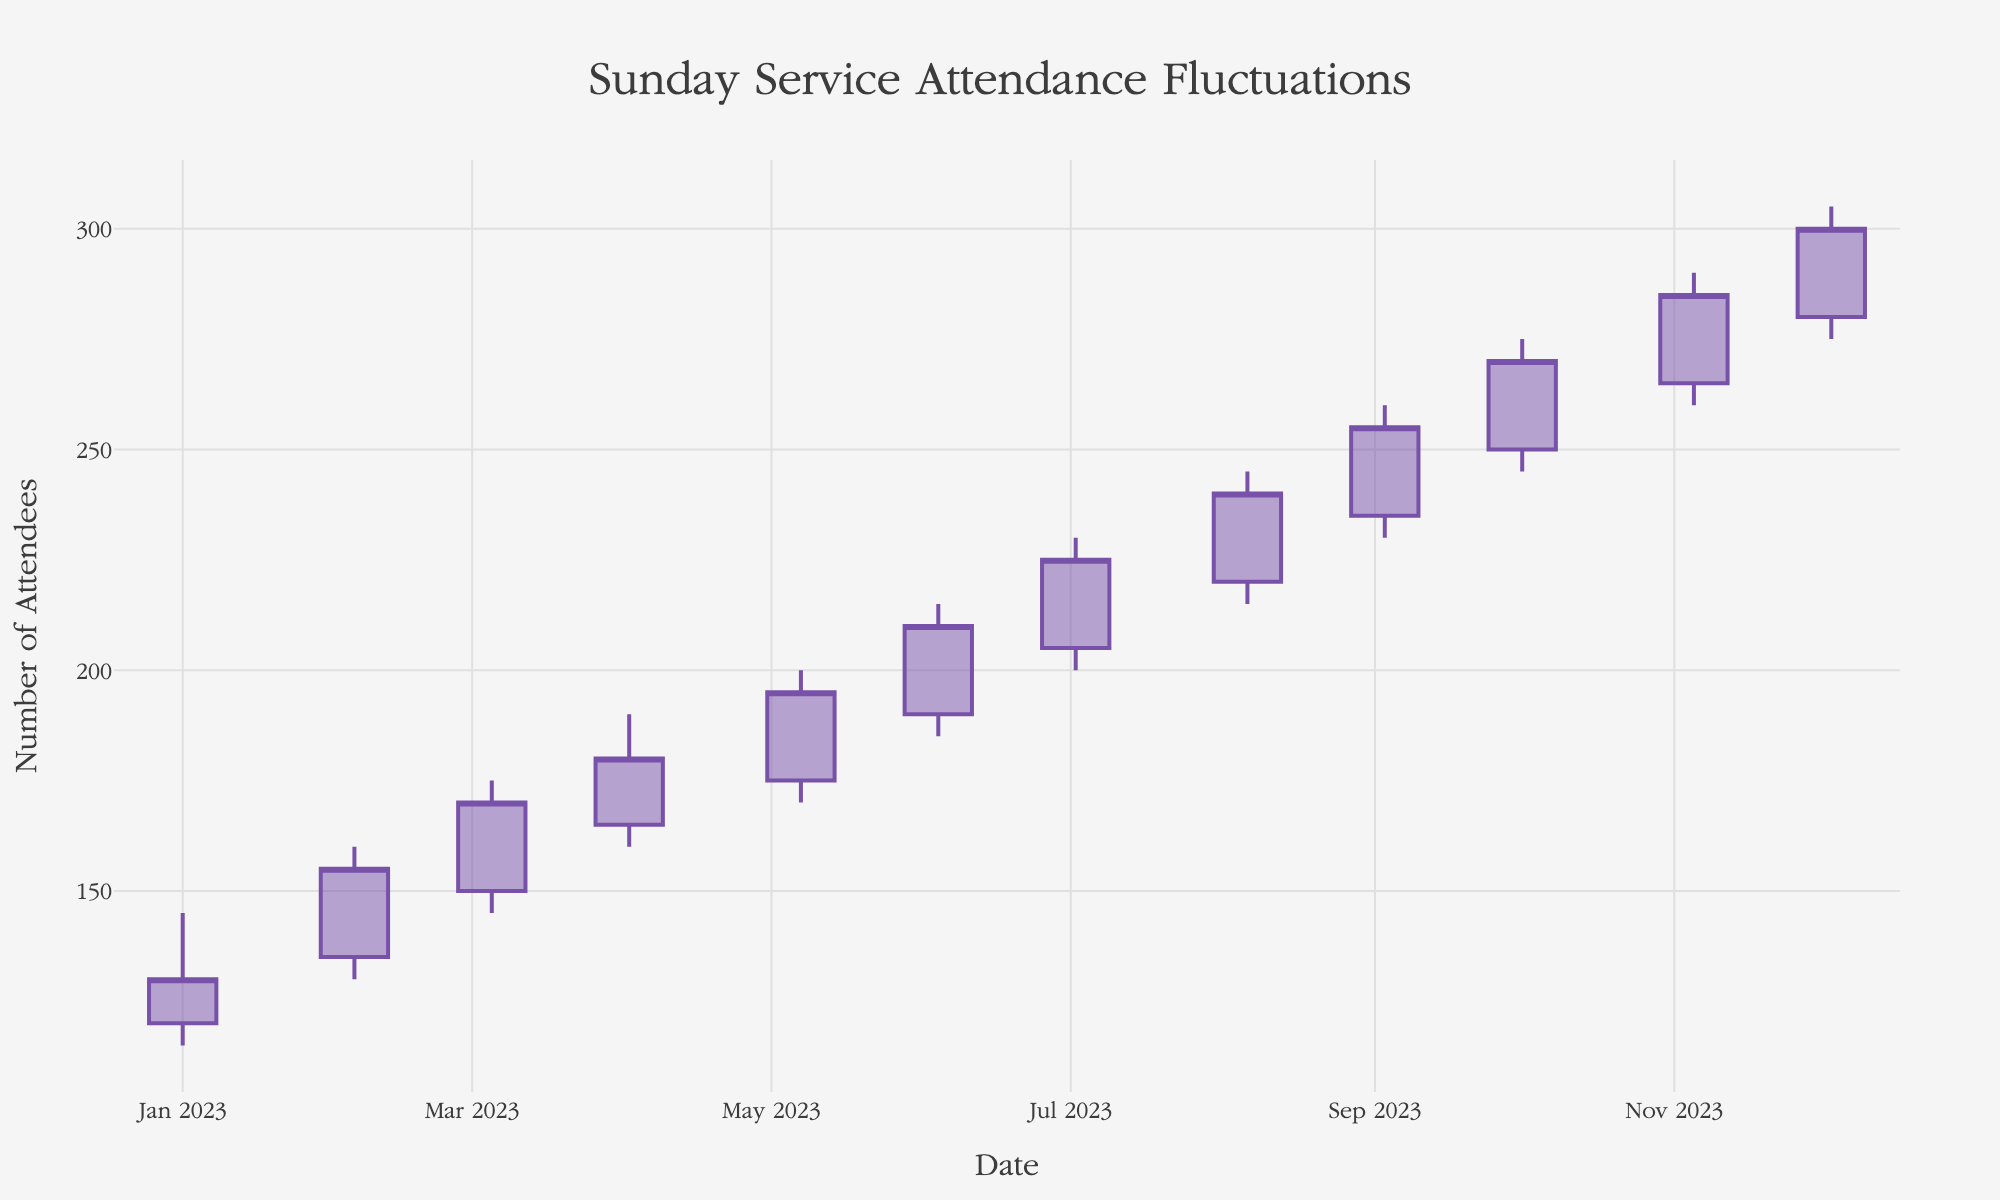What's the title of the chart? The title of the chart is prominently displayed at the top. It reads "Sunday Service Attendance Fluctuations".
Answer: Sunday Service Attendance Fluctuations What is the highest number of attendees recorded for any given Sunday service? The highest number of attendees is represented by the highest 'High' value in the chart, which occurs in December 2023 with a value of 305.
Answer: 305 Which month shows the greatest increase in attendees from the opening to the closing value? To determine the greatest increase, subtract the Open value from the Close value for each month and identify the maximum difference. August has the greatest increase (240 - 220 = 20).
Answer: August How many data points are represented in the chart? Each month from January to December has one OHLC data point, resulting in 12 data points.
Answer: 12 What was the lowest recorded attendance in July? The lowest recorded attendance for each month is given by the 'Low' value. For July, this value is 200.
Answer: 200 Compare the attendance on January and July. Which month had a higher closing value? Compare the 'Close' values for January and July. January's Close value is 130, while July's Close value is 225, indicating July is higher.
Answer: July Which month had the smallest fluctuation in attendance, based on the difference between the high and low values? Calculate the difference between the High and Low values for each month, then identify the smallest difference. January has the smallest fluctuation (145 - 115 = 30).
Answer: January In which months did the attendance close at a higher value than it opened? To determine this, check if the Close values are greater than the Open values for each month. This occurs in every month.
Answer: All months What's the trend in Sunday service attendance from January to December? Observing the increasing trend in the closing values from January (130) to December (300) shows a consistent rise in attendance.
Answer: Increasing How much higher was the highest attendance in September compared to the lowest attendance in April? Subtract the lowest 'Low' value in April (160) from the highest 'High' value in September (260). The result is 100.
Answer: 100 